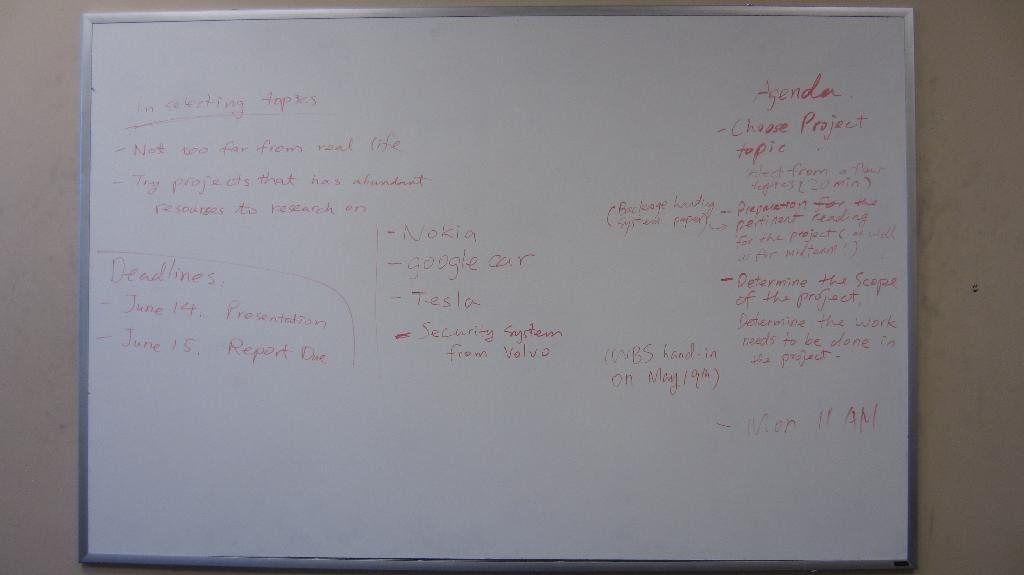<image>
Create a compact narrative representing the image presented. A whiteboard with red marker instructions on selecting topics. 